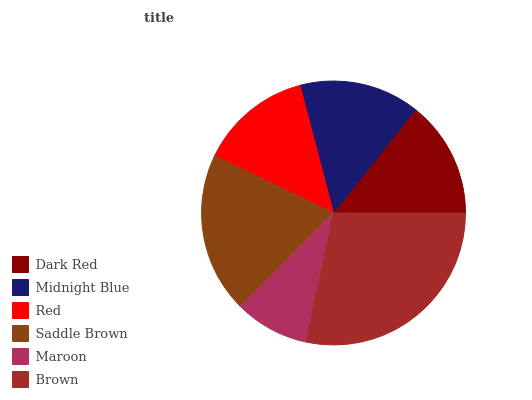Is Maroon the minimum?
Answer yes or no. Yes. Is Brown the maximum?
Answer yes or no. Yes. Is Midnight Blue the minimum?
Answer yes or no. No. Is Midnight Blue the maximum?
Answer yes or no. No. Is Midnight Blue greater than Dark Red?
Answer yes or no. Yes. Is Dark Red less than Midnight Blue?
Answer yes or no. Yes. Is Dark Red greater than Midnight Blue?
Answer yes or no. No. Is Midnight Blue less than Dark Red?
Answer yes or no. No. Is Midnight Blue the high median?
Answer yes or no. Yes. Is Dark Red the low median?
Answer yes or no. Yes. Is Brown the high median?
Answer yes or no. No. Is Maroon the low median?
Answer yes or no. No. 